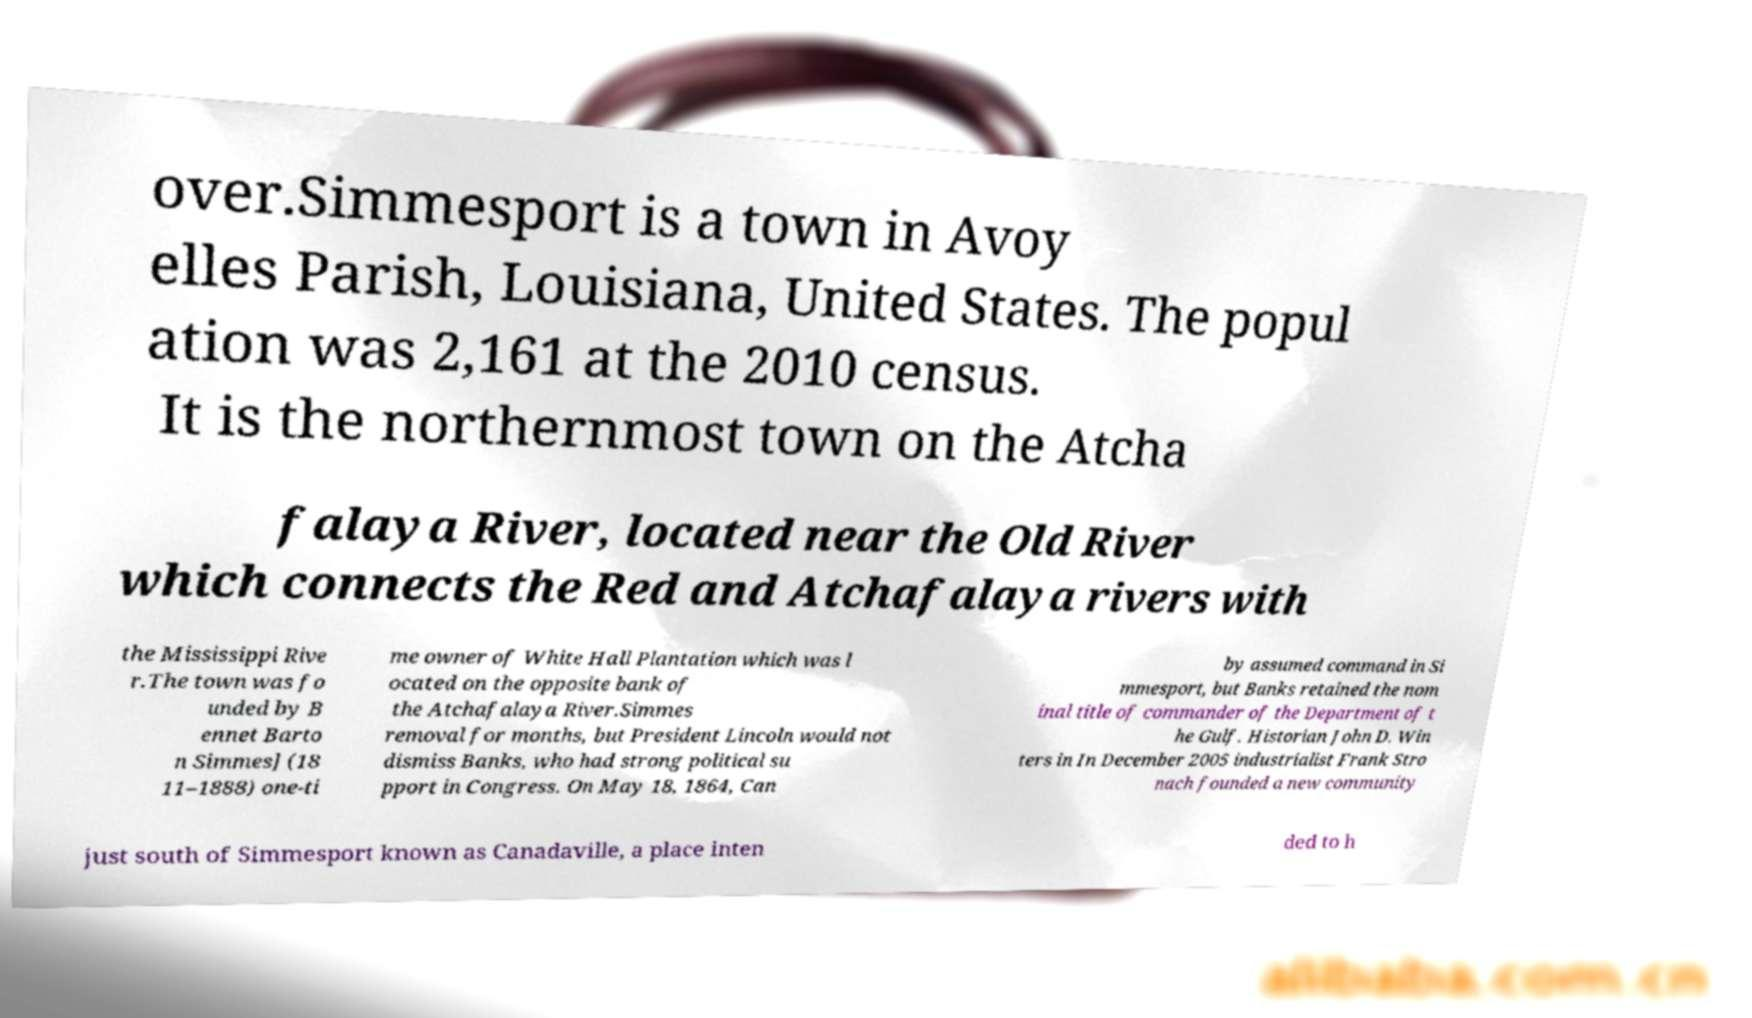There's text embedded in this image that I need extracted. Can you transcribe it verbatim? over.Simmesport is a town in Avoy elles Parish, Louisiana, United States. The popul ation was 2,161 at the 2010 census. It is the northernmost town on the Atcha falaya River, located near the Old River which connects the Red and Atchafalaya rivers with the Mississippi Rive r.The town was fo unded by B ennet Barto n Simmes] (18 11–1888) one-ti me owner of White Hall Plantation which was l ocated on the opposite bank of the Atchafalaya River.Simmes removal for months, but President Lincoln would not dismiss Banks, who had strong political su pport in Congress. On May 18, 1864, Can by assumed command in Si mmesport, but Banks retained the nom inal title of commander of the Department of t he Gulf. Historian John D. Win ters in In December 2005 industrialist Frank Stro nach founded a new community just south of Simmesport known as Canadaville, a place inten ded to h 